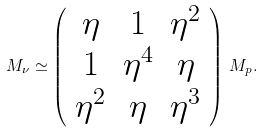Convert formula to latex. <formula><loc_0><loc_0><loc_500><loc_500>M _ { \nu } \simeq \left ( \begin{array} { c c c } { \eta } & { 1 } & { { \eta ^ { 2 } } } \\ { 1 } & { { \eta ^ { 4 } } } & { \eta } \\ { { \eta ^ { 2 } } } & { \eta } & { { \eta ^ { 3 } } } \end{array} \right ) \, M _ { p } .</formula> 